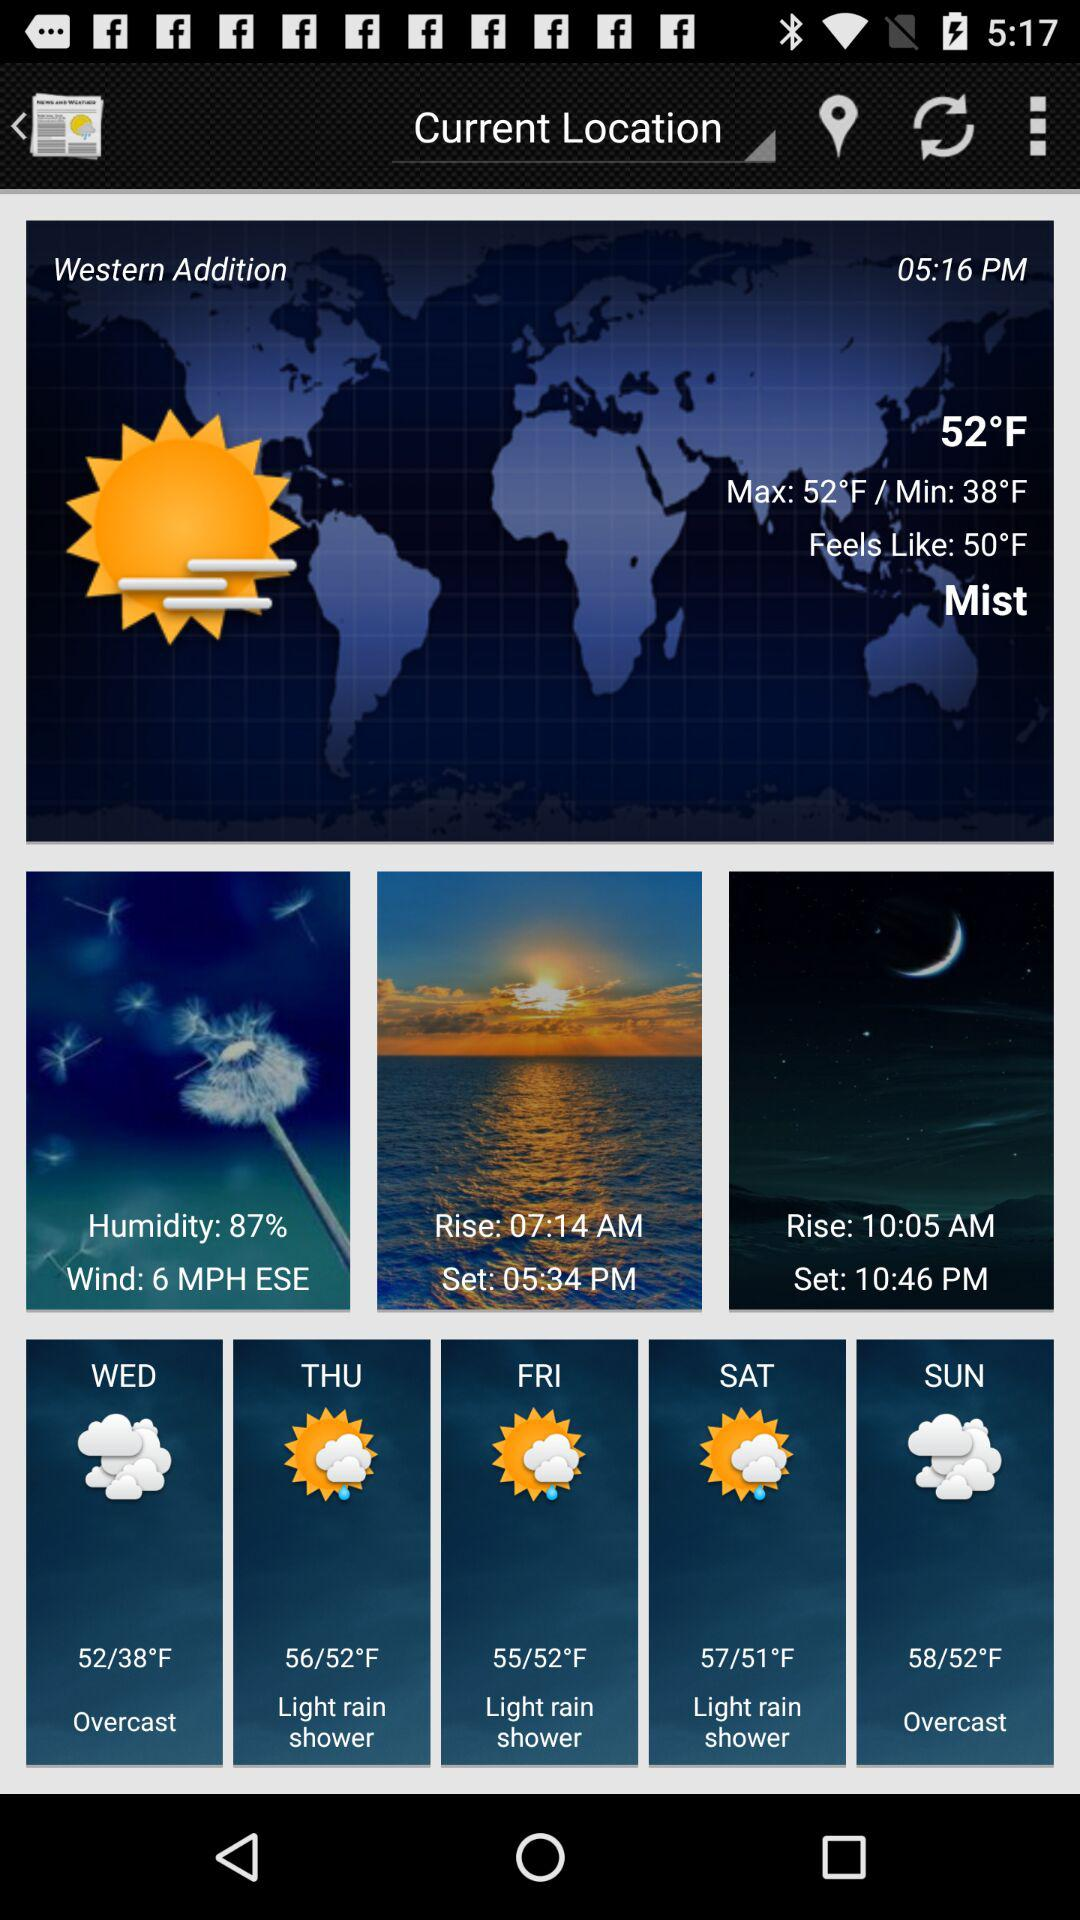What is the wind speed? The wind speed is 6 mph. 